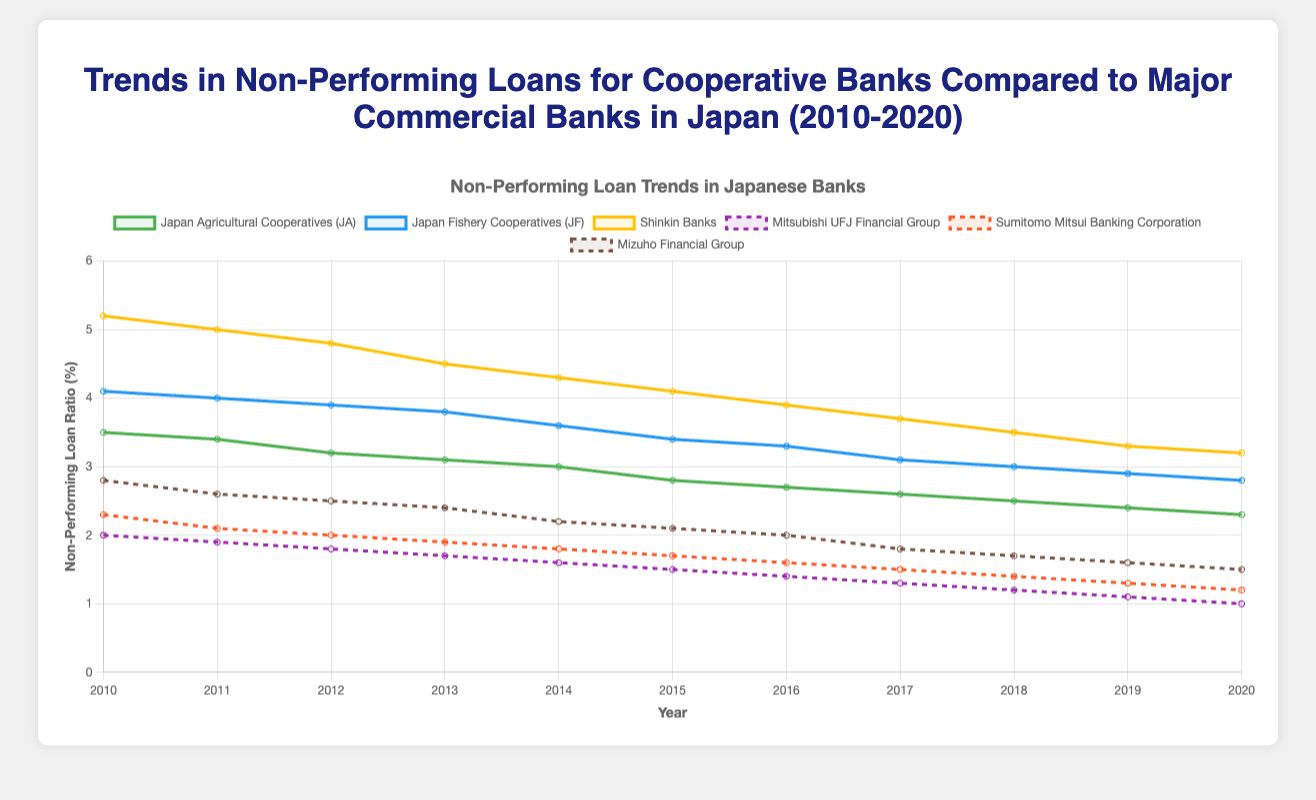What is the trend in Non-Performing Loans (NPL) for Mitsubishi UFJ Financial Group from 2010 to 2020? From 2010 to 2020, the NPL ratio for Mitsubishi UFJ Financial Group steadily declined each year, starting from 2.0% in 2010 and reaching 1.0% by 2020.
Answer: The NPL ratio consistently decreased from 2.0% to 1.0% Which group consistently had the highest NPL ratio throughout 2010-2020? By examining the chart, we can see that the Shinkin Banks consistently had the highest NPL ratio among all other banks from 2010 to 2020. Their NPL ratio started at 5.2% in 2010 and gradually decreased to 3.2% by 2020, but still remained the highest throughout.
Answer: Shinkin Banks How did the NPL ratio for Japan Fishery Cooperatives (JF) change from 2010 to 2020? The NPL ratio for Japan Fishery Cooperatives (JF) decreased gradually each year from 4.1% in 2010 to 2.8% in 2020.
Answer: It decreased from 4.1% to 2.8% Between Japan Agricultural Cooperatives (JA) and Sumitomo Mitsui Banking Corporation, which had a lower NPL ratio in 2015? Looking at the 2015 data points, Japan Agricultural Cooperatives (JA) had an NPL ratio of 2.8%, while Sumitomo Mitsui Banking Corporation had an NPL ratio of 1.7%. Sumitomo Mitsui Banking Corporation had a lower NPL ratio in 2015.
Answer: Sumitomo Mitsui Banking Corporation By how much did the NPL ratio for Shinkin Banks decline from 2010 to 2020? The NPL ratio for Shinkin Banks was 5.2% in 2010 and 3.2% in 2020. The decline can be calculated as 5.2% - 3.2% = 2.0%.
Answer: 2.0% In what year did all banks have an NPL ratio below 3.0%? The chart shows that, by 2020, every bank's NPL ratio had fallen below 3.0%. This marks the year when every bank achieved this lower threshold.
Answer: 2020 What is the average NPL ratio for Sumitomo Mitsui Banking Corporation over the 2010-2020 period? To find the average NPL ratio for Sumitomo Mitsui Banking Corporation over this period, sum all yearly NPL ratios and divide by the number of years:
(2.3 + 2.1 + 2.0 + 1.9 + 1.8 + 1.7 + 1.6 + 1.5 + 1.4 + 1.3 + 1.2) / 11 = 19.8 / 11 = 1.8
Answer: 1.8 Which bank exhibited the fastest decline in NPL ratio from 2010 to 2020? By comparing the decline rates, we notice that Mitsubishi UFJ Financial Group had the fastest decline in NPL ratio, decreasing by 1.0% (2.0% in 2010 to 1.0% in 2020).
Answer: Mitsubishi UFJ Financial Group Among the cooperative banks, which had the lowest NPL ratio in 2016? By examining the 2016 data points for cooperative banks, we see the NPL ratios are as follows: Japan Agricultural Cooperatives (JA) 2.7%, Japan Fishery Cooperatives (JF) 3.3%, and Shinkin Banks 3.9%. The lowest among them is Japan Agricultural Cooperatives (JA) with 2.7%.
Answer: Japan Agricultural Cooperatives (JA) 